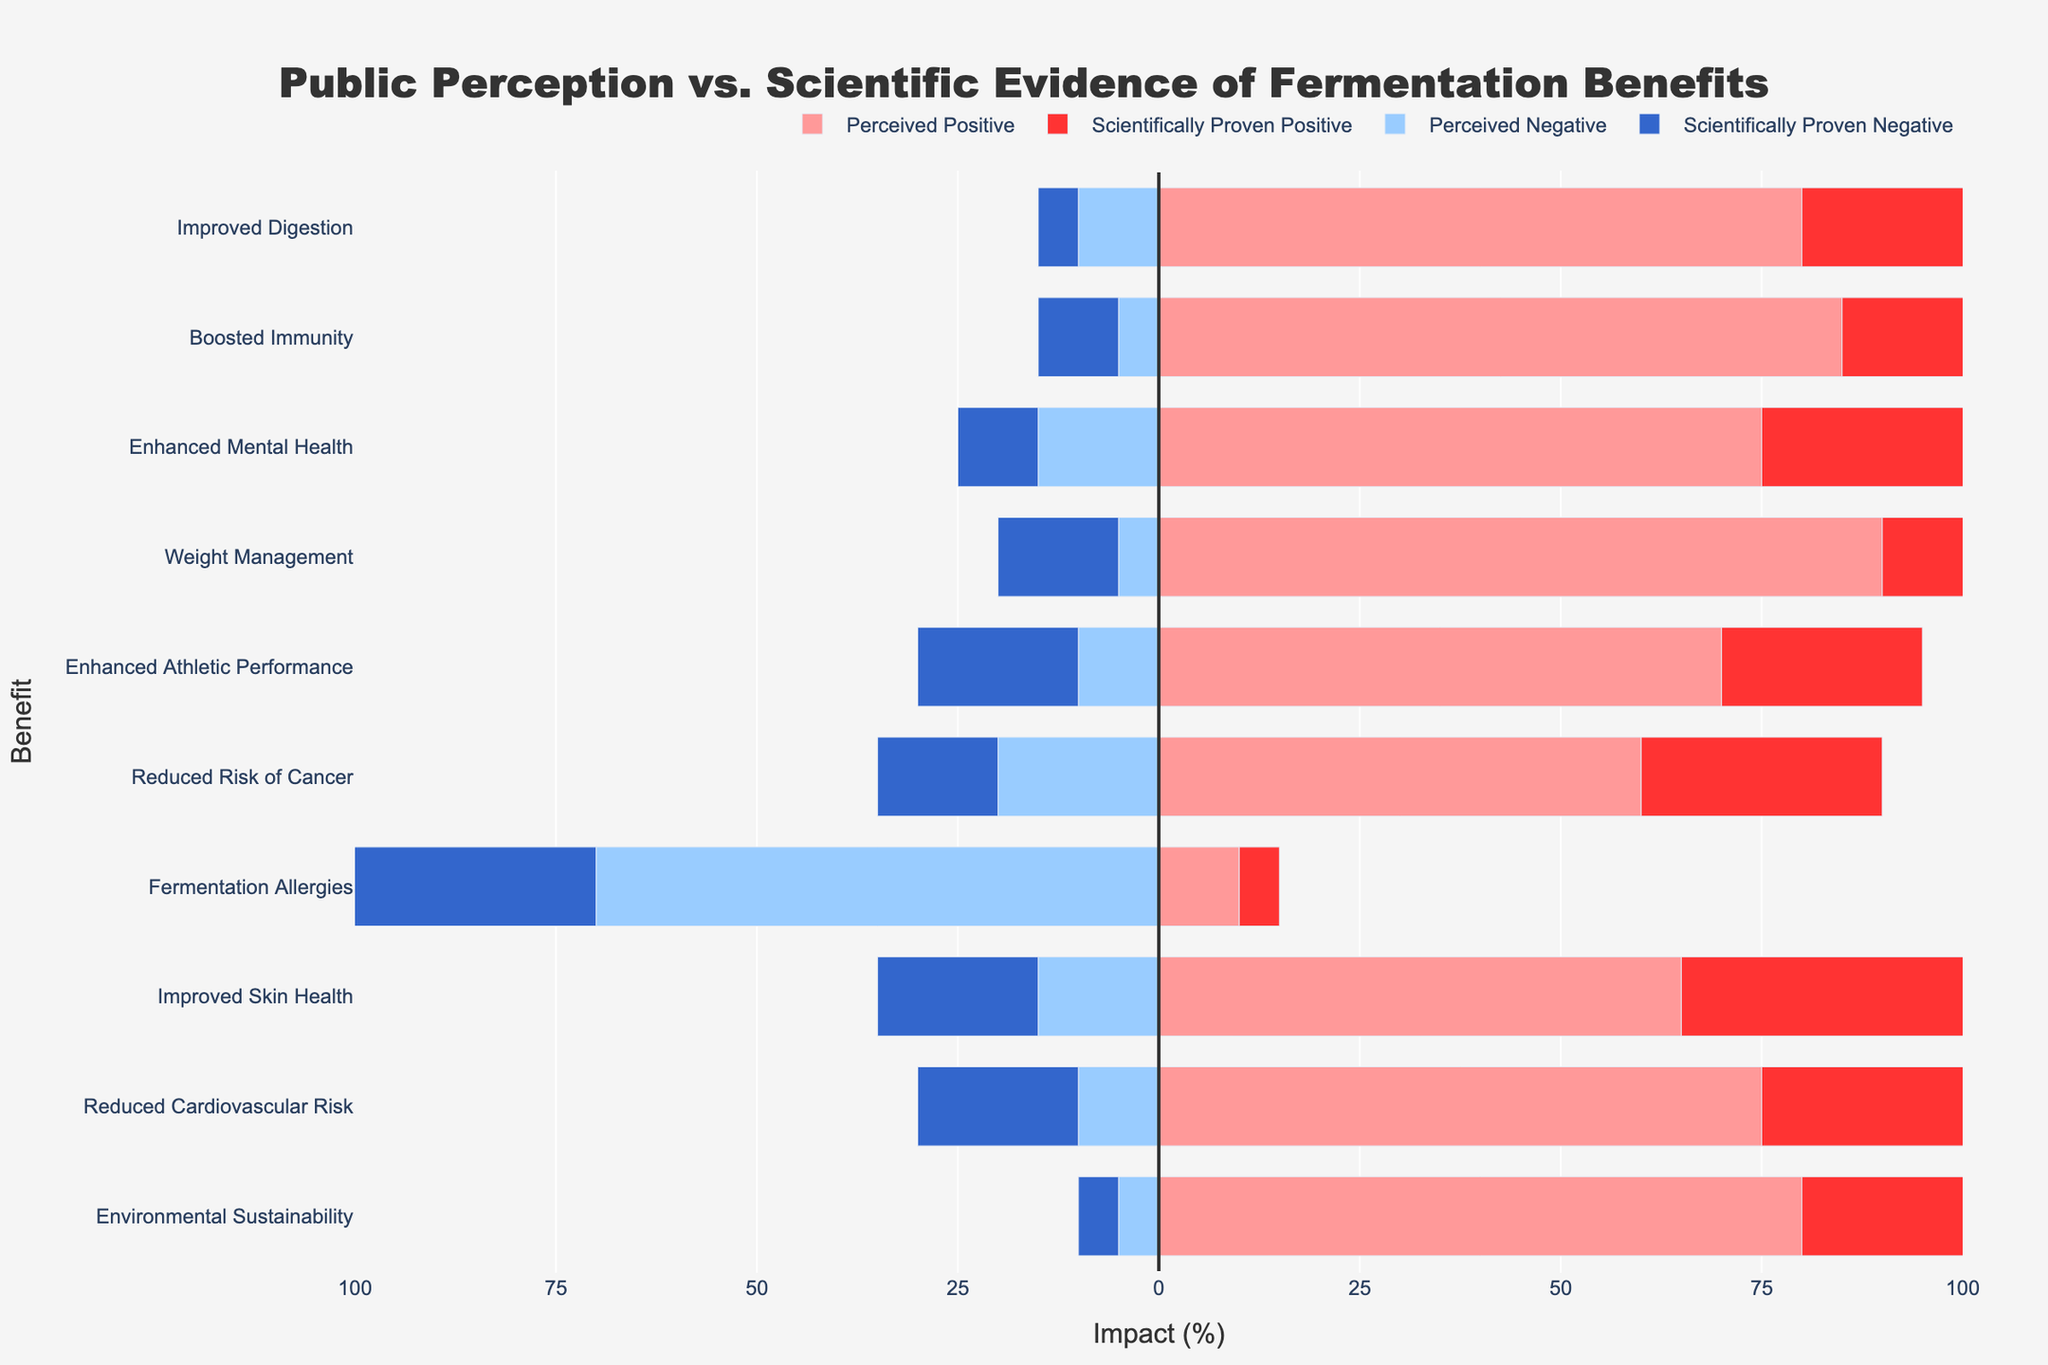What benefit is perceived as having the highest positive impact? The chart shows that the benefit with the highest perceived positive impact is Weight Management, as its bar is the longest among the perceived positive impact sections.
Answer: Weight Management Which benefit shows the largest difference between perceived positive impact and scientifically proven positive impact? To find the largest difference, we subtract the scientifically proven positive impact from the perceived positive impact for each benefit, and compare the differences. Weight Management has the largest difference: 90 (perceived) - 50 (scientifically proven) = 40.
Answer: Weight Management Compare the perceived negative impact and scientifically proven negative impact for Fermentation Allergies. The chart shows perceived and scientifically proven negative impacts as horizontal bars extending to the left. For Fermentation Allergies, the perceived negative impact is 70 and the scientifically proven negative impact is 80. So, the scientifically proven negative impact is higher.
Answer: Scientifically proven negative impact is higher Which benefit has the most visually balanced impacts, positive and negative, both in perception and scientific proof? To find the most balanced impacts, we need to check for a roughly equal length of bars for positive and negative impacts in both perceptions and scientific proofs. Environmental Sustainability shows this balance, as its perceived positive impact (80) and perceived negative impact (5), and scientifically proven positive impact (75) and scientifically proven negative impact (5) have relatively small differences.
Answer: Environmental Sustainability For Improved Digestion, calculate the total perceived impact and the total scientifically proven impact separately. For perceived impacts, add the positive (80) and negative (10) values: 80 - 10 = 70. For scientifically proven impacts, add the positive (70) and negative (5) values: 70 - 5 = 65.
Answer: Total perceived impact: 70, Total scientifically proven impact: 65 Which benefit is perceived to have a negative impact by the least percentage? By looking at the lengths of the bars for perceived negative impact, Environmental Sustainability is perceived to have the least negative impact, with a percentage of 5.
Answer: Environmental Sustainability Which benefit's scientifically proven positive impact is more than double its scientifically proven negative impact? By comparing each benefit, only Improved Digestion has a scientifically proven positive impact (70) that is more than double its scientifically proven negative impact (5).
Answer: Improved Digestion Is there any benefit where the perceived negative impact is equal to the scientifically proven negative impact? The chart shows bars of equal length for perceived and scientifically proven negative impacts. Environmental Sustainability has both perceived and scientifically proven negative impacts of 5.
Answer: Environmental Sustainability Which benefit's perceived positive impact is at least twice that of the scientifically proven positive impact? By examining each benefit, Weight Management's perceived positive impact (90) is at least twice that of its scientifically proven positive impact (50).
Answer: Weight Management 